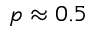Convert formula to latex. <formula><loc_0><loc_0><loc_500><loc_500>p \approx 0 . 5</formula> 